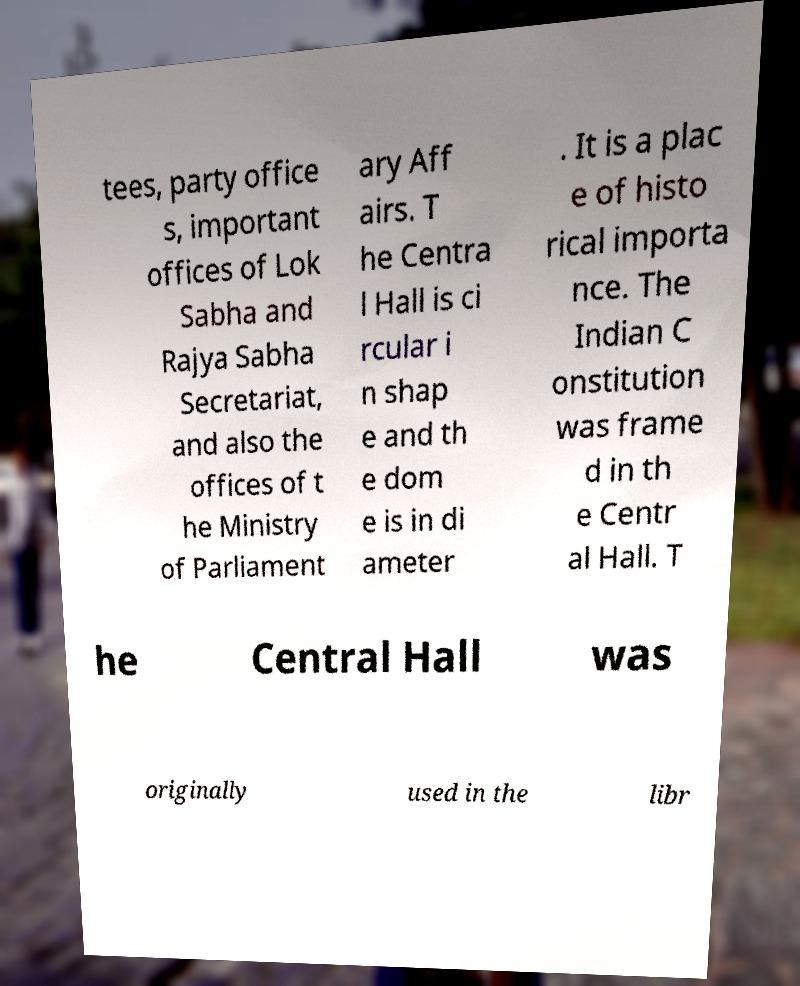There's text embedded in this image that I need extracted. Can you transcribe it verbatim? tees, party office s, important offices of Lok Sabha and Rajya Sabha Secretariat, and also the offices of t he Ministry of Parliament ary Aff airs. T he Centra l Hall is ci rcular i n shap e and th e dom e is in di ameter . It is a plac e of histo rical importa nce. The Indian C onstitution was frame d in th e Centr al Hall. T he Central Hall was originally used in the libr 